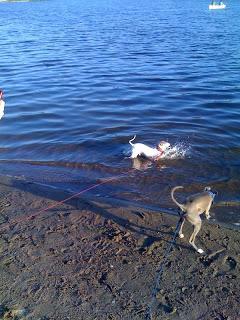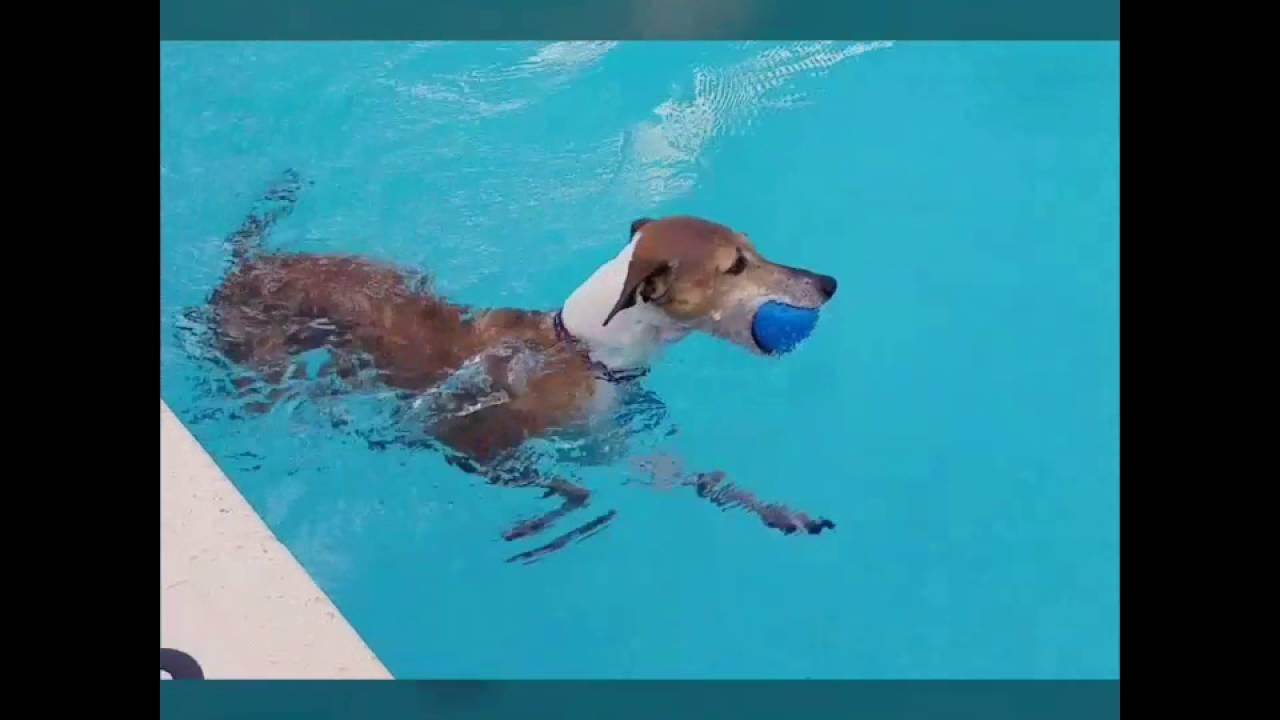The first image is the image on the left, the second image is the image on the right. Assess this claim about the two images: "At least one dog is standing on land.". Correct or not? Answer yes or no. Yes. 